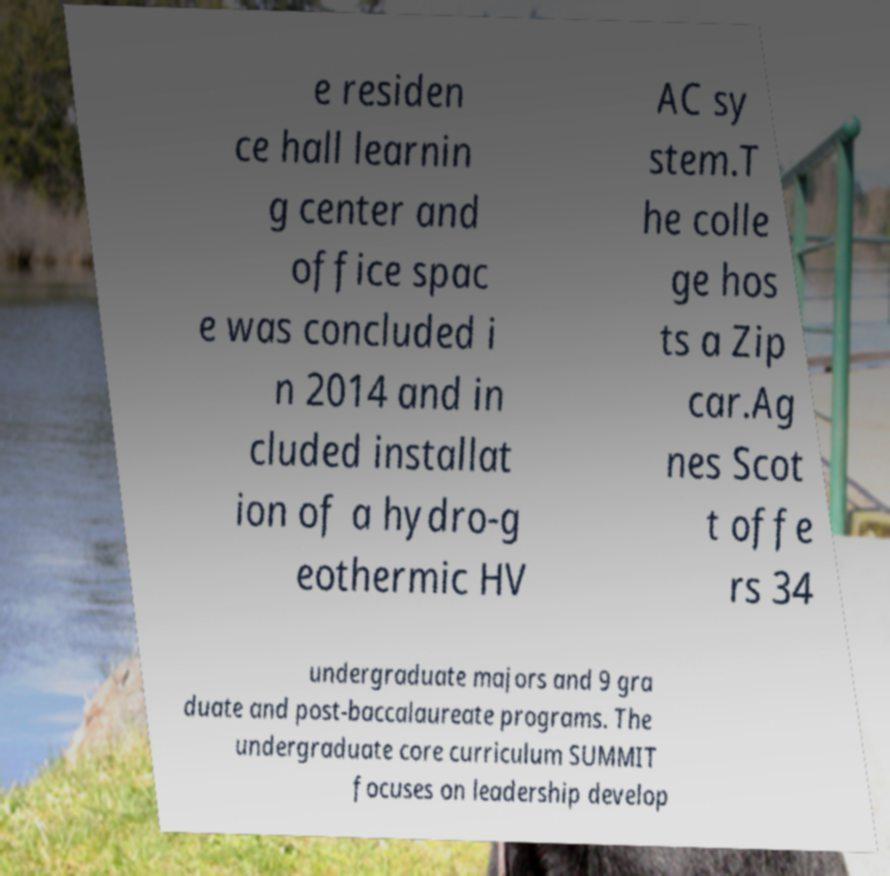For documentation purposes, I need the text within this image transcribed. Could you provide that? e residen ce hall learnin g center and office spac e was concluded i n 2014 and in cluded installat ion of a hydro-g eothermic HV AC sy stem.T he colle ge hos ts a Zip car.Ag nes Scot t offe rs 34 undergraduate majors and 9 gra duate and post-baccalaureate programs. The undergraduate core curriculum SUMMIT focuses on leadership develop 